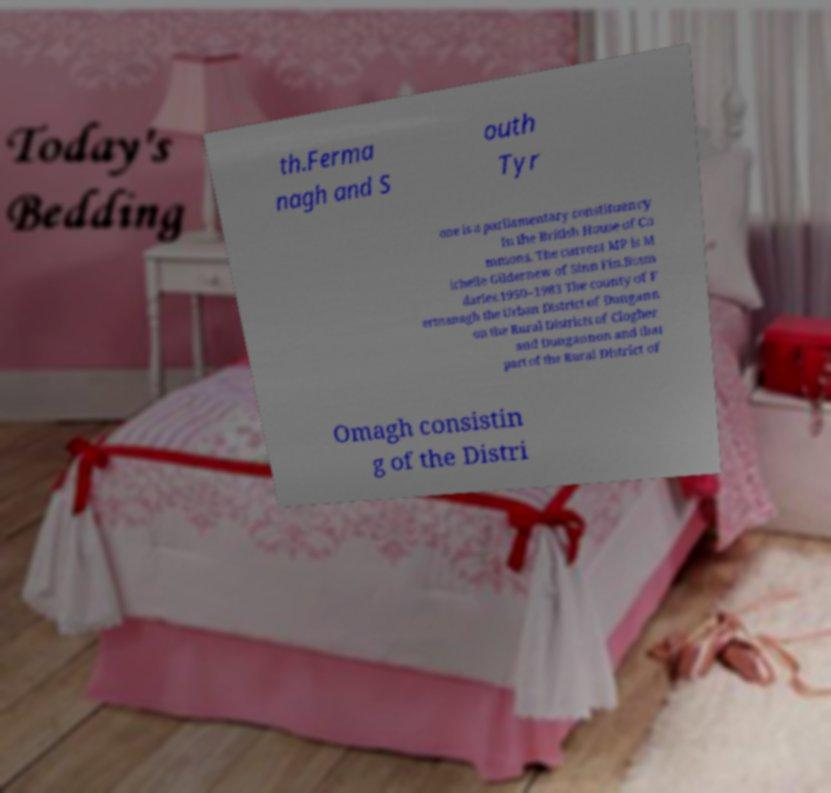I need the written content from this picture converted into text. Can you do that? th.Ferma nagh and S outh Tyr one is a parliamentary constituency in the British House of Co mmons. The current MP is M ichelle Gildernew of Sinn Fin.Boun daries.1950–1983 The county of F ermanagh the Urban District of Dungann on the Rural Districts of Clogher and Dungannon and that part of the Rural District of Omagh consistin g of the Distri 